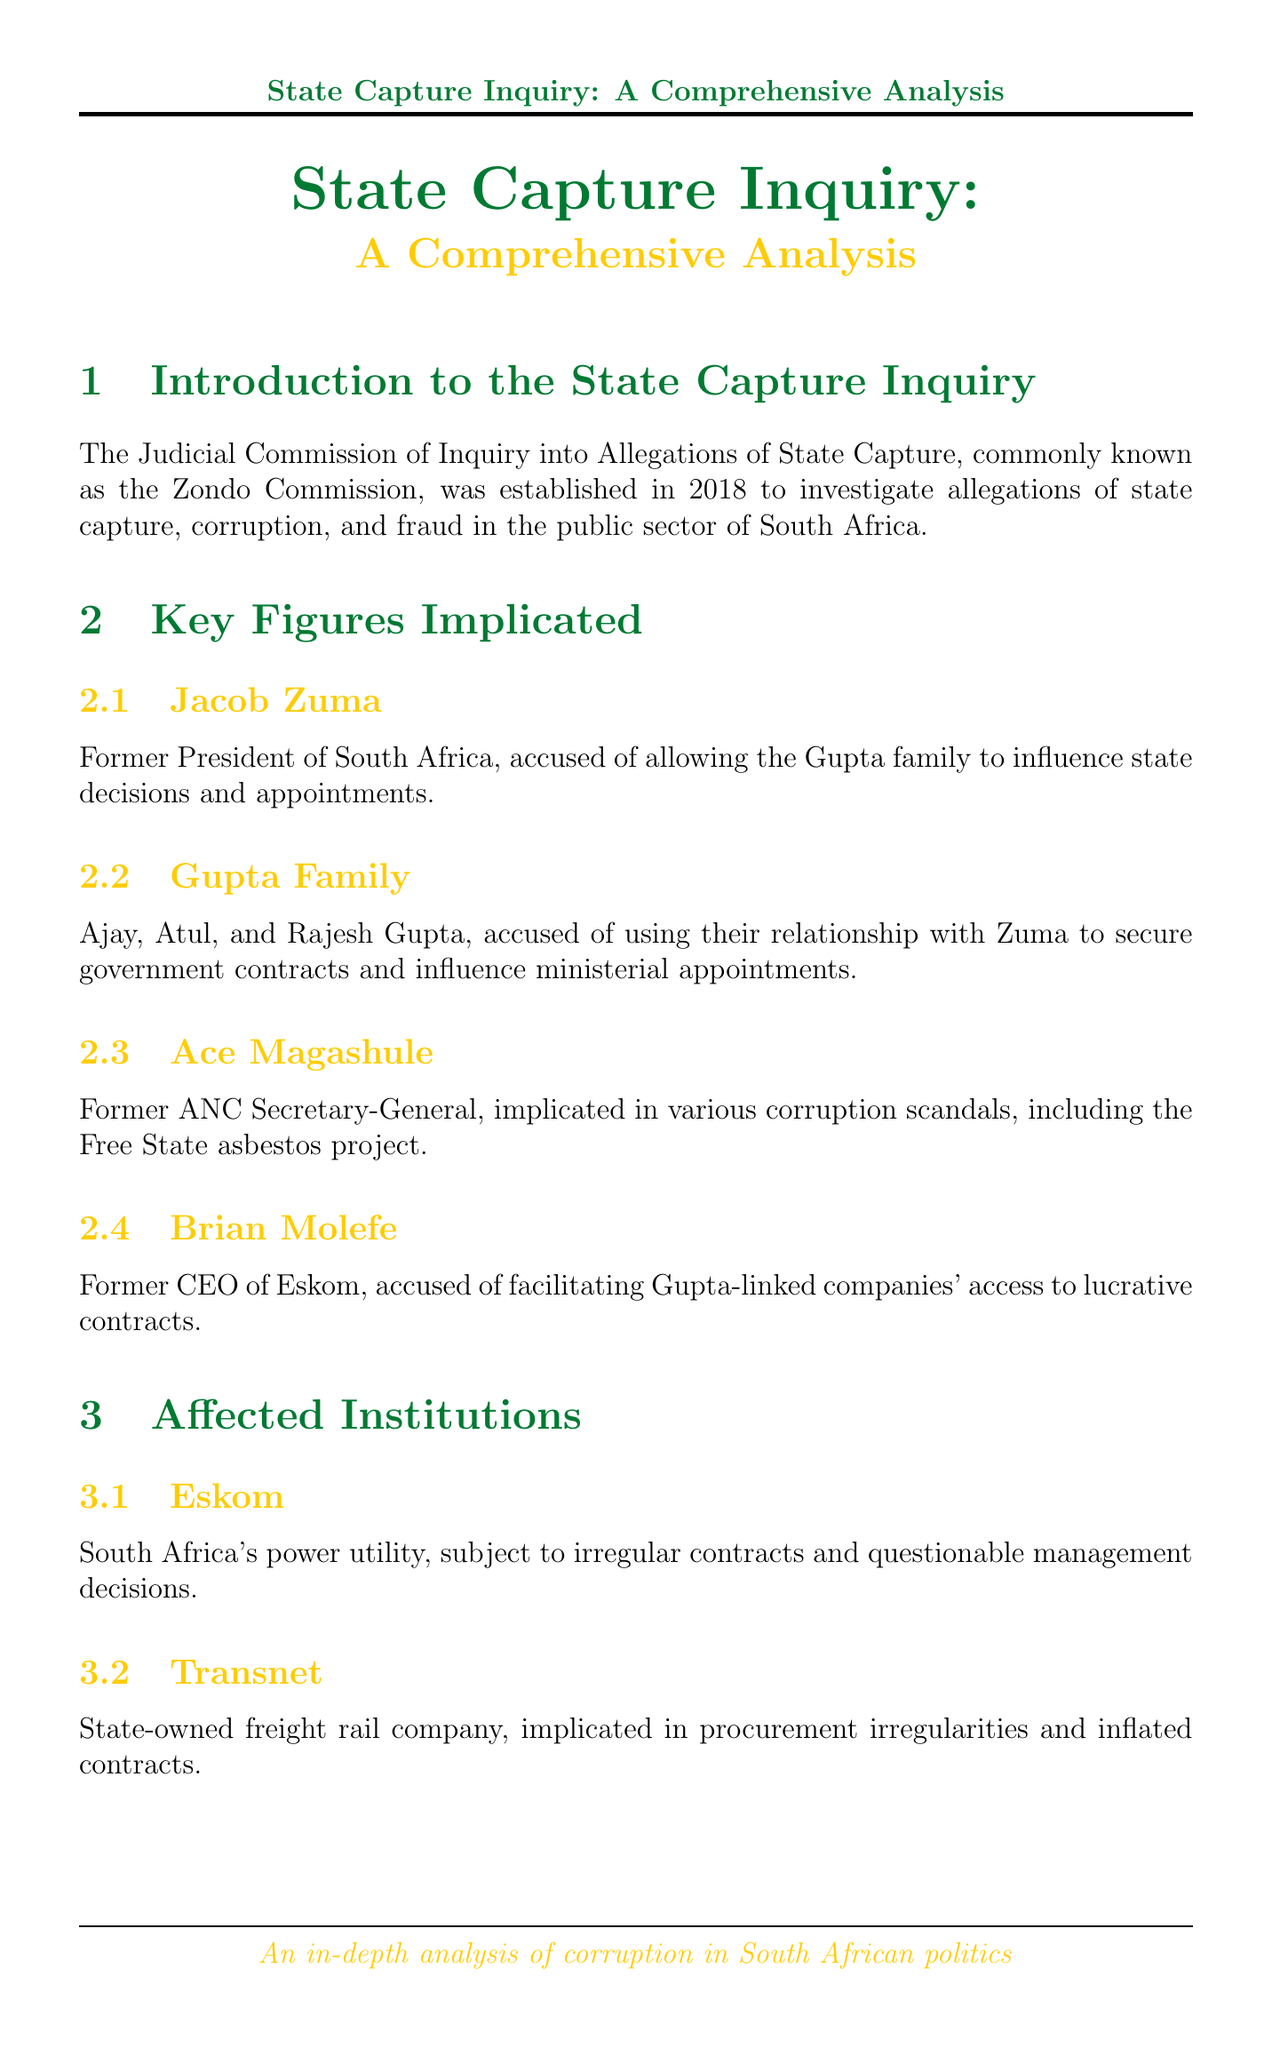What is the name of the commission investigating state capture? The document mentions the commission as the Judicial Commission of Inquiry into Allegations of State Capture, also known as the Zondo Commission.
Answer: Zondo Commission Who is accused of allowing the Gupta family to influence state decisions? Jacob Zuma is identified in the document as the former president accused of allowing this influence.
Answer: Jacob Zuma Which family is implicated in the inquiry? The document explicitly names the Gupta family, consisting of Ajay, Atul, and Rajesh Gupta, as implicated.
Answer: Gupta Family What institution is South Africa's power utility mentioned in the document? Eskom is the power utility identified in the document as being affected by irregular contracts.
Answer: Eskom What is the Estina Dairy Farm Project associated with? The document states that it was a failed agricultural project allegedly used to siphon millions to Gupta-linked companies.
Answer: Siphon millions to Gupta-linked companies Who initiated several cases based on the commission's findings? The document specifies that the National Prosecuting Authority (NPA) took this action based on the inquiry's findings.
Answer: National Prosecuting Authority What economic impact has state capture had on South Africa? The document indicates that state capture has cost South Africa hundreds of billions of rands and has contributed to economic stagnation.
Answer: Hundreds of billions of rands What recommendation does the Zondo Commission make to prevent future state capture? The document mentions strengthening anti-corruption bodies as one of the key recommendations made by the commission.
Answer: Strengthening anti-corruption bodies 